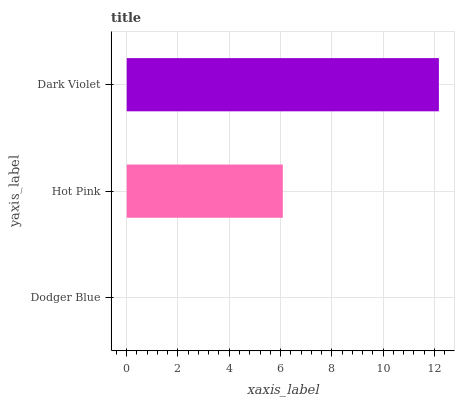Is Dodger Blue the minimum?
Answer yes or no. Yes. Is Dark Violet the maximum?
Answer yes or no. Yes. Is Hot Pink the minimum?
Answer yes or no. No. Is Hot Pink the maximum?
Answer yes or no. No. Is Hot Pink greater than Dodger Blue?
Answer yes or no. Yes. Is Dodger Blue less than Hot Pink?
Answer yes or no. Yes. Is Dodger Blue greater than Hot Pink?
Answer yes or no. No. Is Hot Pink less than Dodger Blue?
Answer yes or no. No. Is Hot Pink the high median?
Answer yes or no. Yes. Is Hot Pink the low median?
Answer yes or no. Yes. Is Dodger Blue the high median?
Answer yes or no. No. Is Dodger Blue the low median?
Answer yes or no. No. 